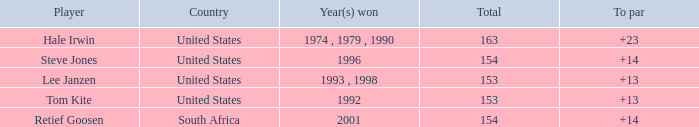What is the total that South Africa had a par greater than 14 None. 